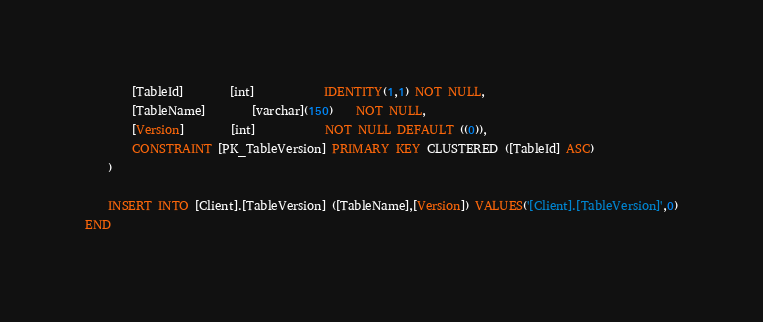Convert code to text. <code><loc_0><loc_0><loc_500><loc_500><_SQL_>		[TableId]		[int]			IDENTITY(1,1) NOT NULL,
		[TableName]		[varchar](150)	NOT NULL,
		[Version]		[int]			NOT NULL DEFAULT ((0)),
		CONSTRAINT [PK_TableVersion] PRIMARY KEY CLUSTERED ([TableId] ASC)
	)
	
	INSERT INTO [Client].[TableVersion] ([TableName],[Version]) VALUES('[Client].[TableVersion]',0)
END</code> 